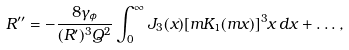Convert formula to latex. <formula><loc_0><loc_0><loc_500><loc_500>R ^ { \prime \prime } = - \frac { 8 \gamma _ { \phi } } { ( R ^ { \prime } ) ^ { 3 } Q ^ { 2 } } \int _ { 0 } ^ { \infty } J _ { 3 } ( x ) [ m K _ { 1 } ( m x ) ] ^ { 3 } x \, d x + \dots ,</formula> 